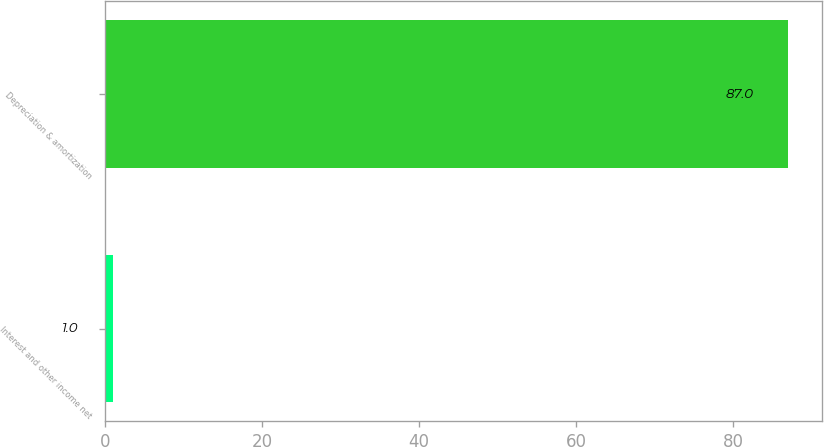Convert chart to OTSL. <chart><loc_0><loc_0><loc_500><loc_500><bar_chart><fcel>Interest and other income net<fcel>Depreciation & amortization<nl><fcel>1<fcel>87<nl></chart> 